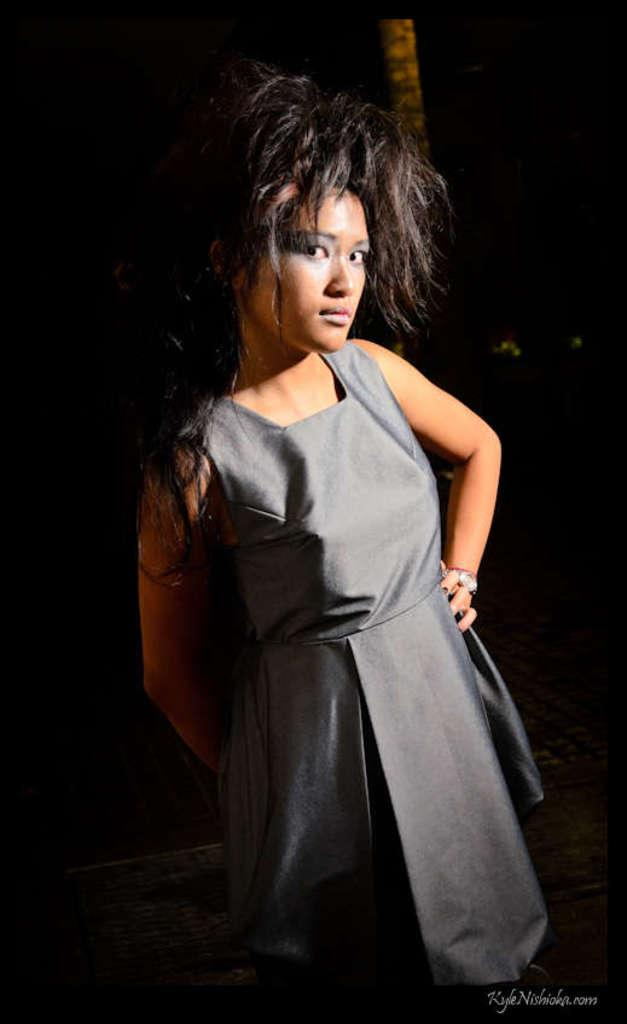Who is the main subject in the image? There is a woman in the image. What is the woman wearing? The woman is wearing a gray dress. What can be observed about the background of the image? The background of the image is dark. What type of roll can be seen in the woman's hand in the image? There is no roll present in the image; the woman is not holding anything in her hand. 